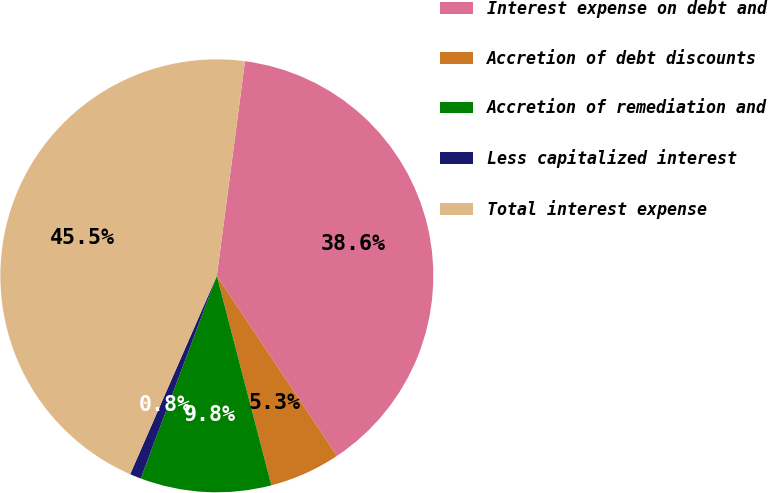Convert chart to OTSL. <chart><loc_0><loc_0><loc_500><loc_500><pie_chart><fcel>Interest expense on debt and<fcel>Accretion of debt discounts<fcel>Accretion of remediation and<fcel>Less capitalized interest<fcel>Total interest expense<nl><fcel>38.56%<fcel>5.31%<fcel>9.77%<fcel>0.84%<fcel>45.52%<nl></chart> 